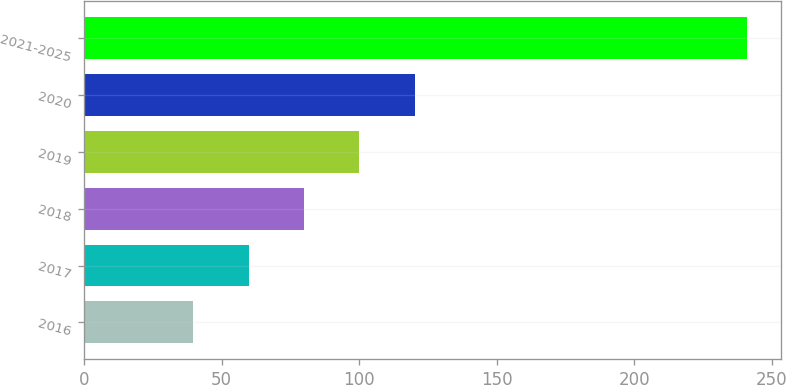Convert chart. <chart><loc_0><loc_0><loc_500><loc_500><bar_chart><fcel>2016<fcel>2017<fcel>2018<fcel>2019<fcel>2020<fcel>2021-2025<nl><fcel>39.7<fcel>59.84<fcel>79.98<fcel>100.12<fcel>120.26<fcel>241.1<nl></chart> 